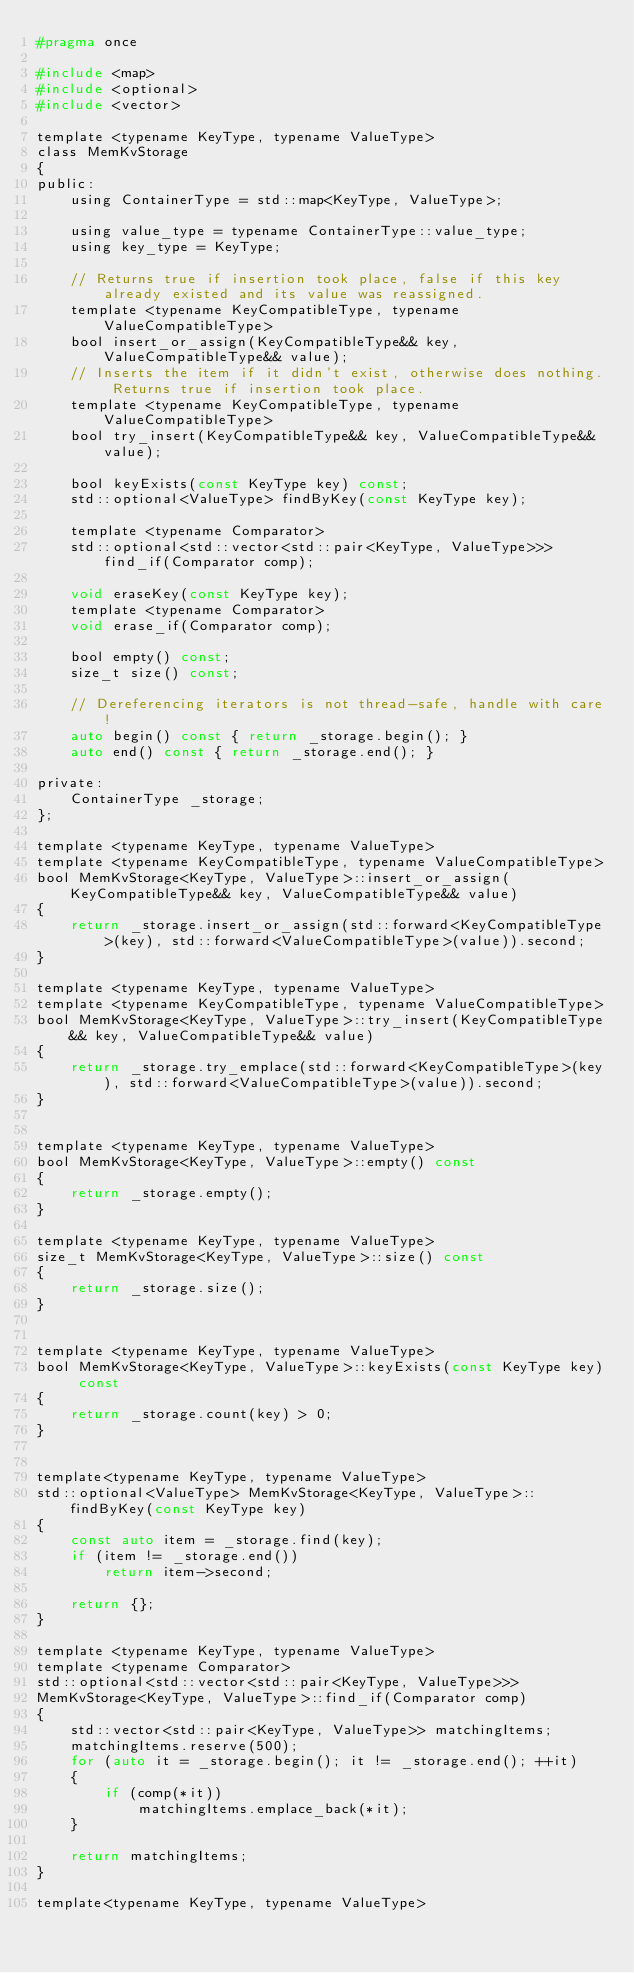<code> <loc_0><loc_0><loc_500><loc_500><_C_>#pragma once

#include <map>
#include <optional>
#include <vector>

template <typename KeyType, typename ValueType>
class MemKvStorage
{
public:
	using ContainerType = std::map<KeyType, ValueType>;

	using value_type = typename ContainerType::value_type;
	using key_type = KeyType;

	// Returns true if insertion took place, false if this key already existed and its value was reassigned.
	template <typename KeyCompatibleType, typename ValueCompatibleType>
	bool insert_or_assign(KeyCompatibleType&& key, ValueCompatibleType&& value);
	// Inserts the item if it didn't exist, otherwise does nothing. Returns true if insertion took place.
	template <typename KeyCompatibleType, typename ValueCompatibleType>
	bool try_insert(KeyCompatibleType&& key, ValueCompatibleType&& value);

	bool keyExists(const KeyType key) const;
	std::optional<ValueType> findByKey(const KeyType key);

	template <typename Comparator>
	std::optional<std::vector<std::pair<KeyType, ValueType>>> find_if(Comparator comp);

	void eraseKey(const KeyType key);
	template <typename Comparator>
	void erase_if(Comparator comp);

	bool empty() const;
	size_t size() const;

	// Dereferencing iterators is not thread-safe, handle with care!
	auto begin() const { return _storage.begin(); }
	auto end() const { return _storage.end(); }

private:
	ContainerType _storage;
};

template <typename KeyType, typename ValueType>
template <typename KeyCompatibleType, typename ValueCompatibleType>
bool MemKvStorage<KeyType, ValueType>::insert_or_assign(KeyCompatibleType&& key, ValueCompatibleType&& value)
{
	return _storage.insert_or_assign(std::forward<KeyCompatibleType>(key), std::forward<ValueCompatibleType>(value)).second;
}

template <typename KeyType, typename ValueType>
template <typename KeyCompatibleType, typename ValueCompatibleType>
bool MemKvStorage<KeyType, ValueType>::try_insert(KeyCompatibleType&& key, ValueCompatibleType&& value)
{
	return _storage.try_emplace(std::forward<KeyCompatibleType>(key), std::forward<ValueCompatibleType>(value)).second;
}


template <typename KeyType, typename ValueType>
bool MemKvStorage<KeyType, ValueType>::empty() const
{
	return _storage.empty();
}

template <typename KeyType, typename ValueType>
size_t MemKvStorage<KeyType, ValueType>::size() const
{
	return _storage.size();
}


template <typename KeyType, typename ValueType>
bool MemKvStorage<KeyType, ValueType>::keyExists(const KeyType key) const
{
	return _storage.count(key) > 0;
}


template<typename KeyType, typename ValueType>
std::optional<ValueType> MemKvStorage<KeyType, ValueType>::findByKey(const KeyType key)
{
	const auto item = _storage.find(key);
	if (item != _storage.end())
		return item->second;

	return {};
}

template <typename KeyType, typename ValueType>
template <typename Comparator>
std::optional<std::vector<std::pair<KeyType, ValueType>>>
MemKvStorage<KeyType, ValueType>::find_if(Comparator comp)
{
	std::vector<std::pair<KeyType, ValueType>> matchingItems;
	matchingItems.reserve(500);
	for (auto it = _storage.begin(); it != _storage.end(); ++it)
	{
		if (comp(*it))
			matchingItems.emplace_back(*it);
	}

	return matchingItems;
}

template<typename KeyType, typename ValueType></code> 